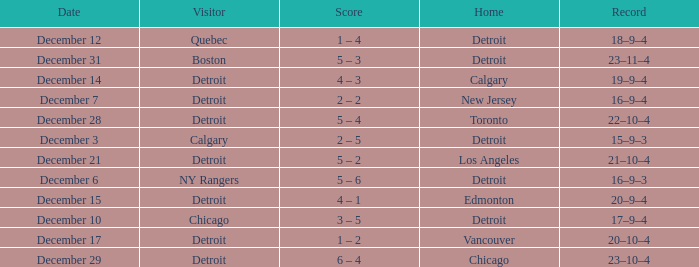Who is the visitor on december 3? Calgary. 